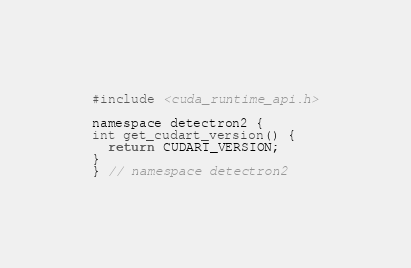Convert code to text. <code><loc_0><loc_0><loc_500><loc_500><_Cuda_>#include <cuda_runtime_api.h>

namespace detectron2 {
int get_cudart_version() {
  return CUDART_VERSION;
}
} // namespace detectron2
</code> 